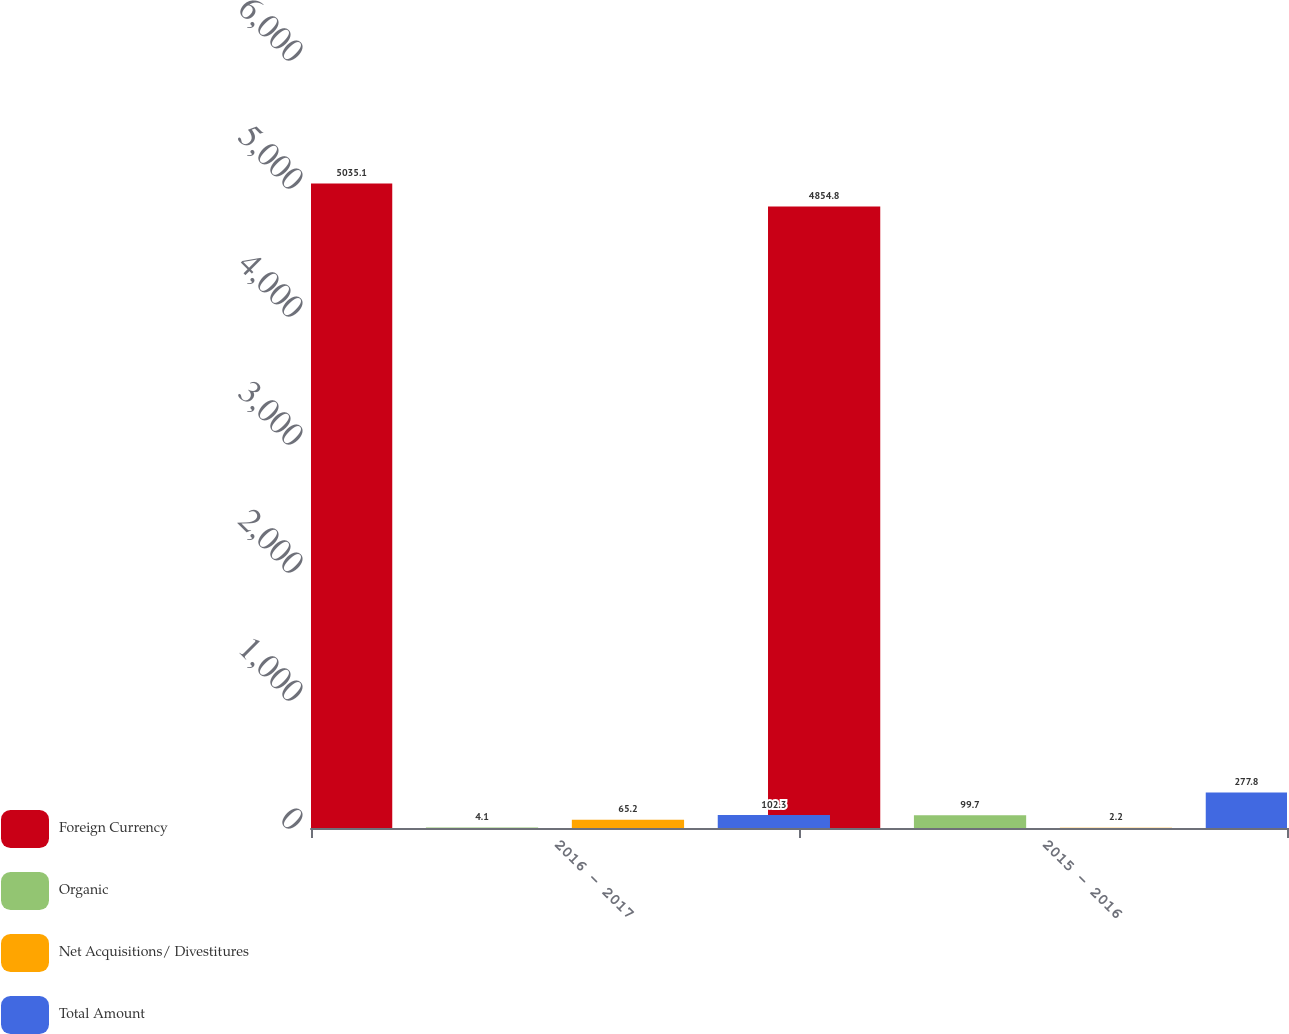<chart> <loc_0><loc_0><loc_500><loc_500><stacked_bar_chart><ecel><fcel>2016 - 2017<fcel>2015 - 2016<nl><fcel>Foreign Currency<fcel>5035.1<fcel>4854.8<nl><fcel>Organic<fcel>4.1<fcel>99.7<nl><fcel>Net Acquisitions/ Divestitures<fcel>65.2<fcel>2.2<nl><fcel>Total Amount<fcel>102.3<fcel>277.8<nl></chart> 